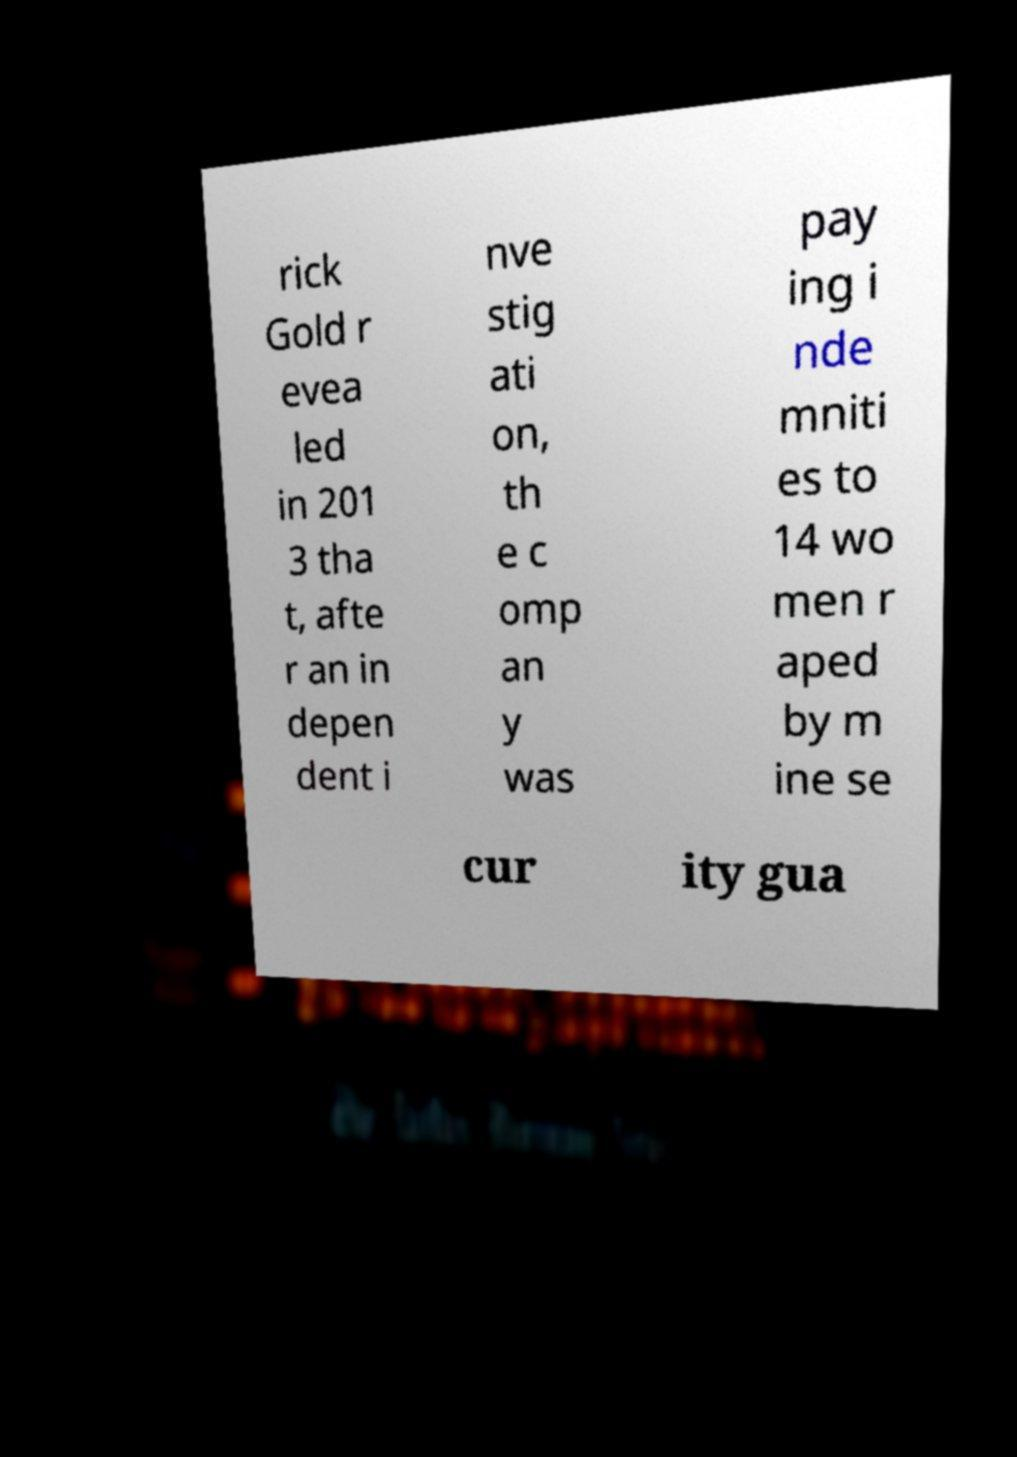Could you extract and type out the text from this image? rick Gold r evea led in 201 3 tha t, afte r an in depen dent i nve stig ati on, th e c omp an y was pay ing i nde mniti es to 14 wo men r aped by m ine se cur ity gua 